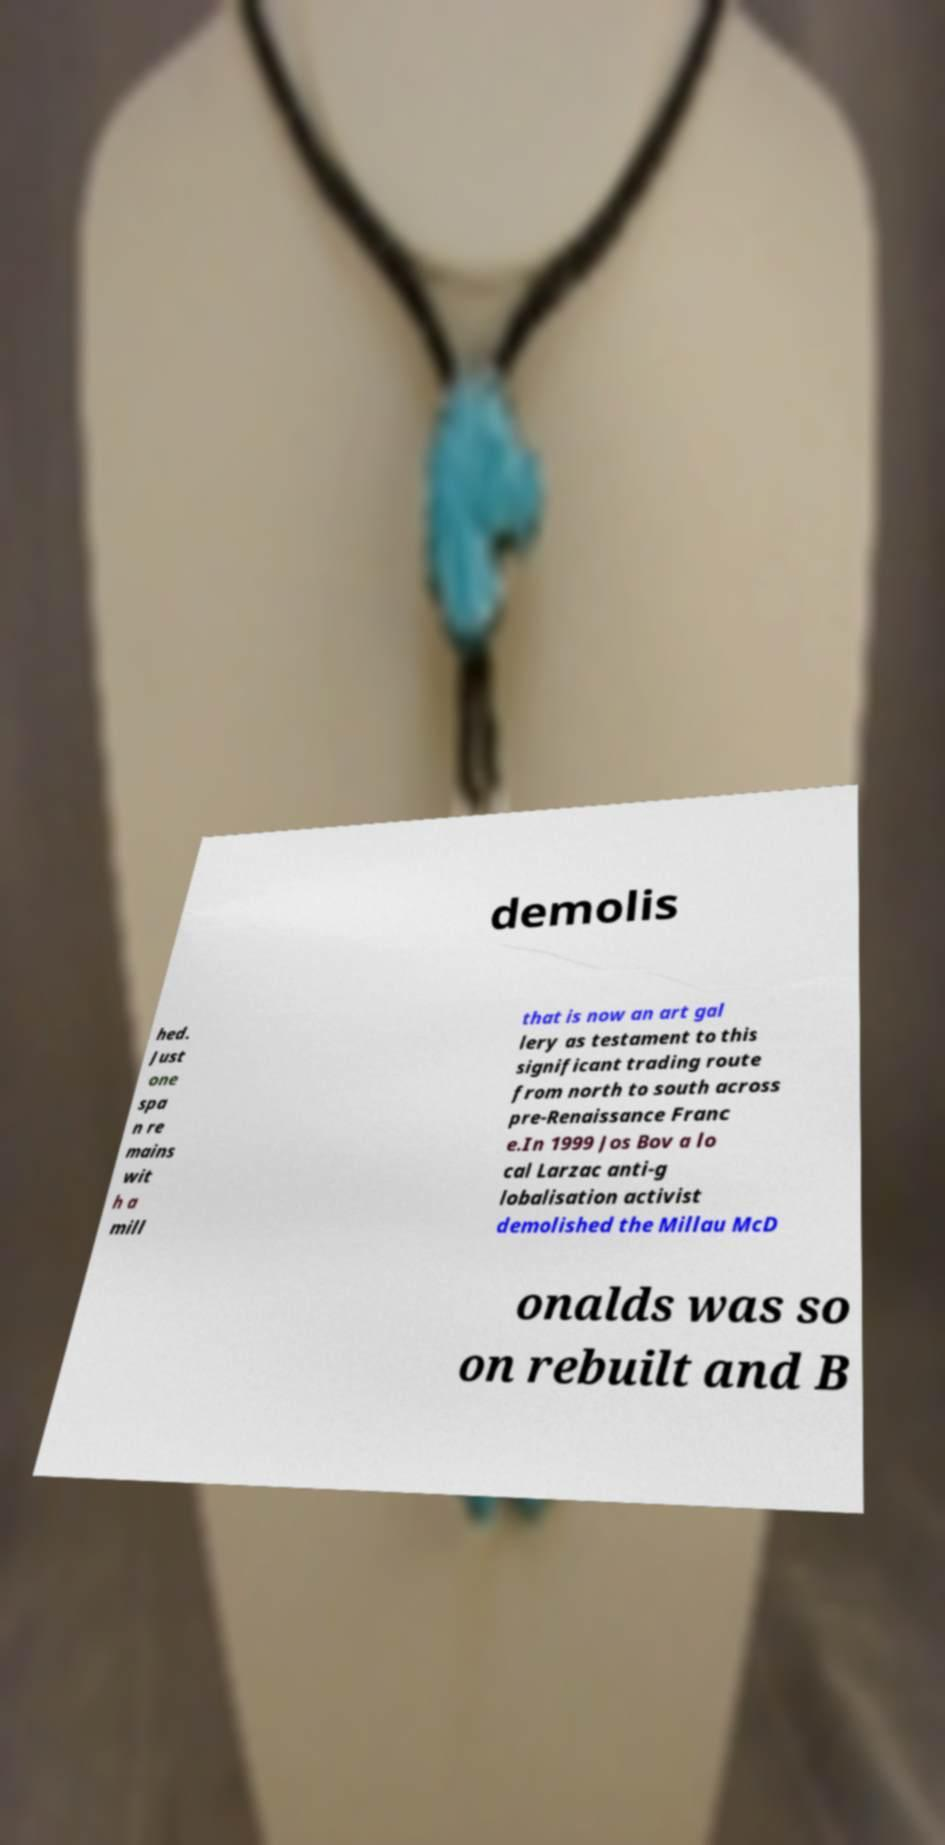There's text embedded in this image that I need extracted. Can you transcribe it verbatim? demolis hed. Just one spa n re mains wit h a mill that is now an art gal lery as testament to this significant trading route from north to south across pre-Renaissance Franc e.In 1999 Jos Bov a lo cal Larzac anti-g lobalisation activist demolished the Millau McD onalds was so on rebuilt and B 